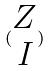<formula> <loc_0><loc_0><loc_500><loc_500>( \begin{matrix} Z \\ I \end{matrix} )</formula> 